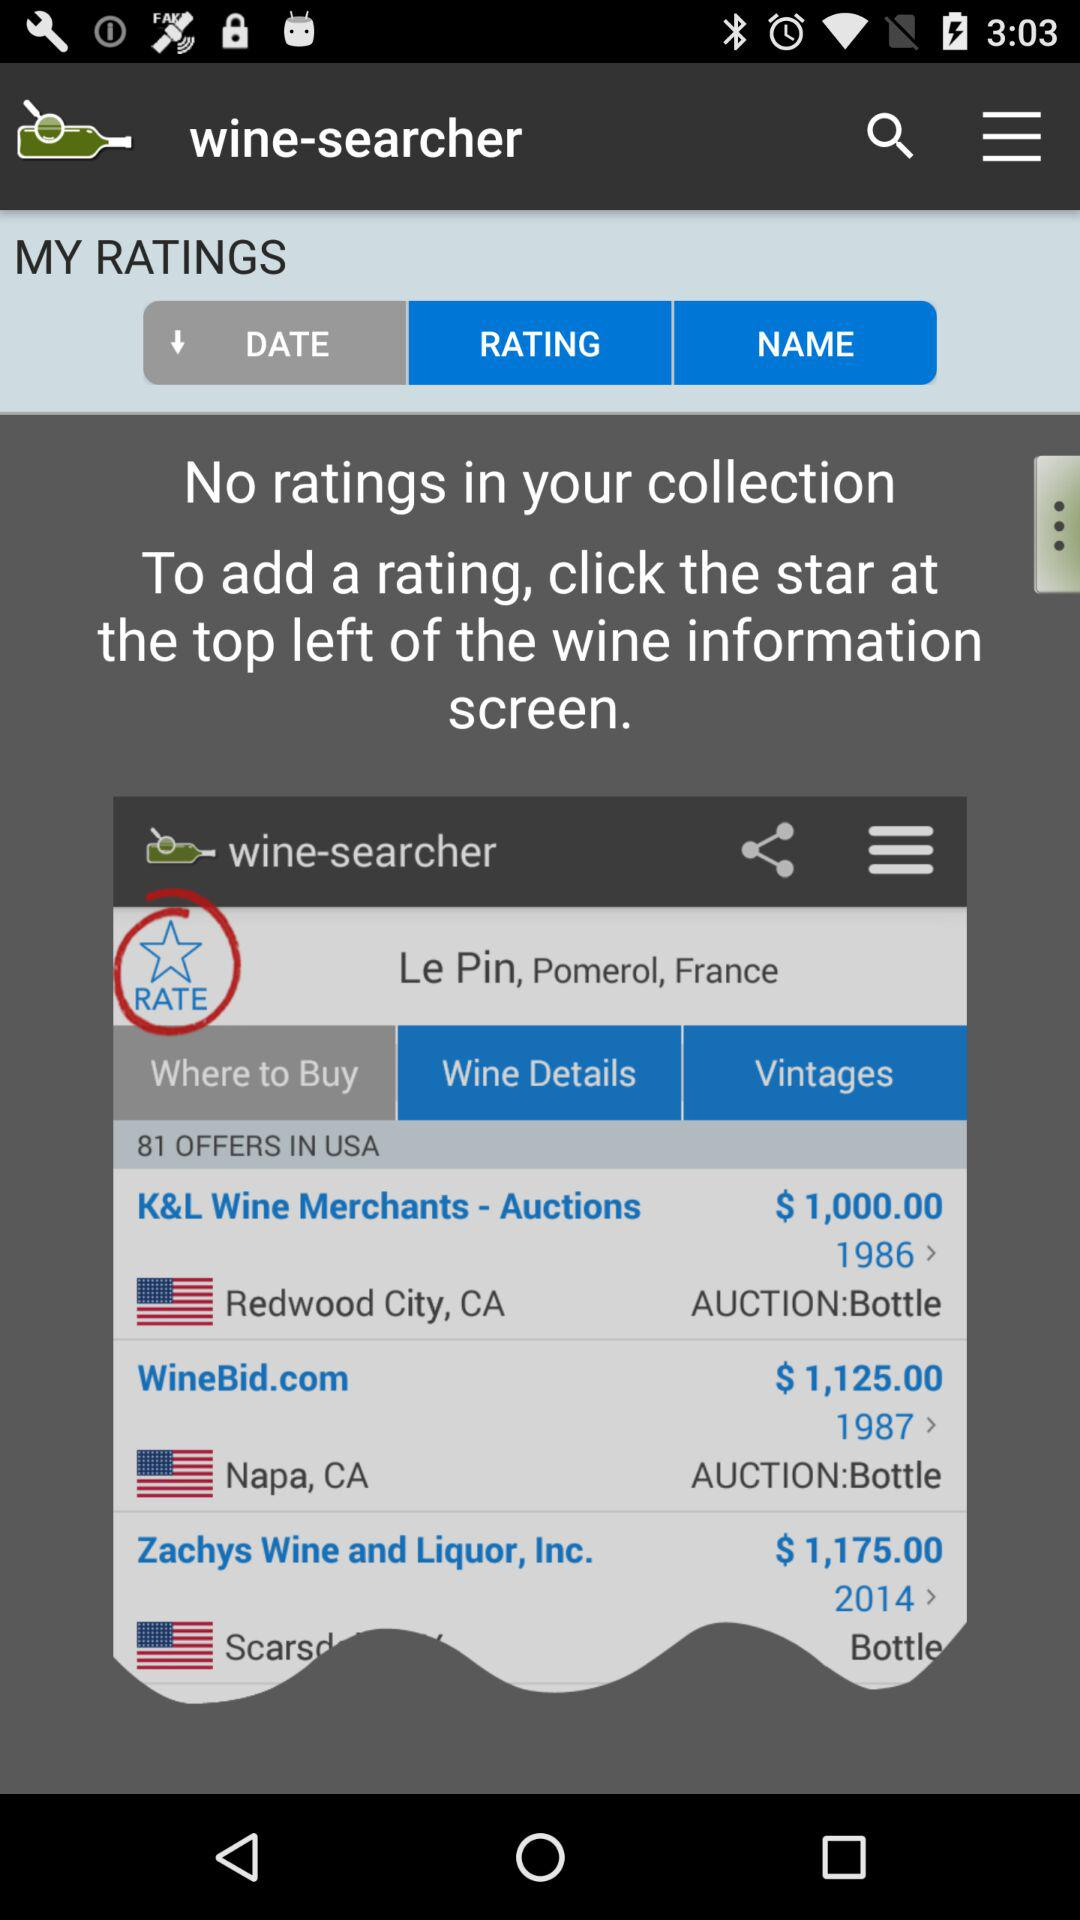How many ratings are there in the collection? There is no rating in your collection. 